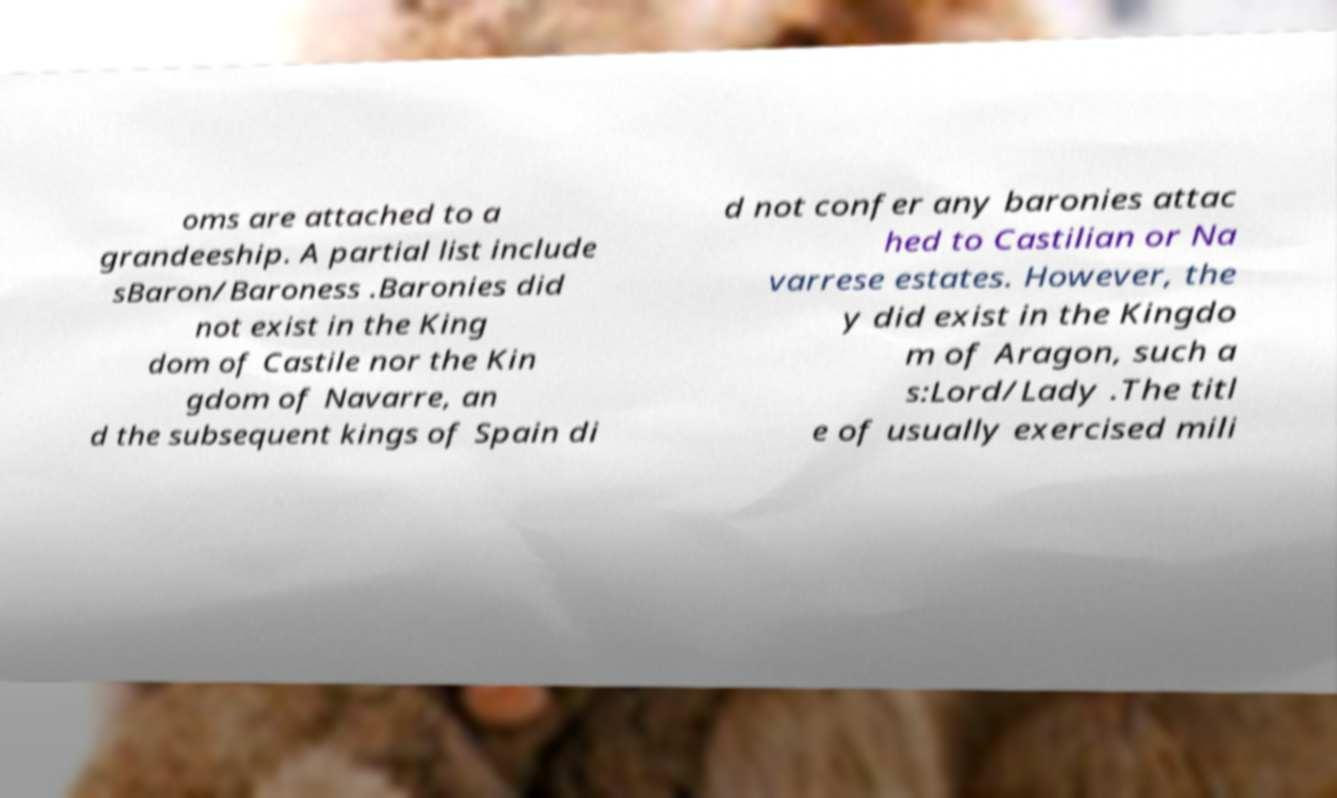Could you extract and type out the text from this image? oms are attached to a grandeeship. A partial list include sBaron/Baroness .Baronies did not exist in the King dom of Castile nor the Kin gdom of Navarre, an d the subsequent kings of Spain di d not confer any baronies attac hed to Castilian or Na varrese estates. However, the y did exist in the Kingdo m of Aragon, such a s:Lord/Lady .The titl e of usually exercised mili 